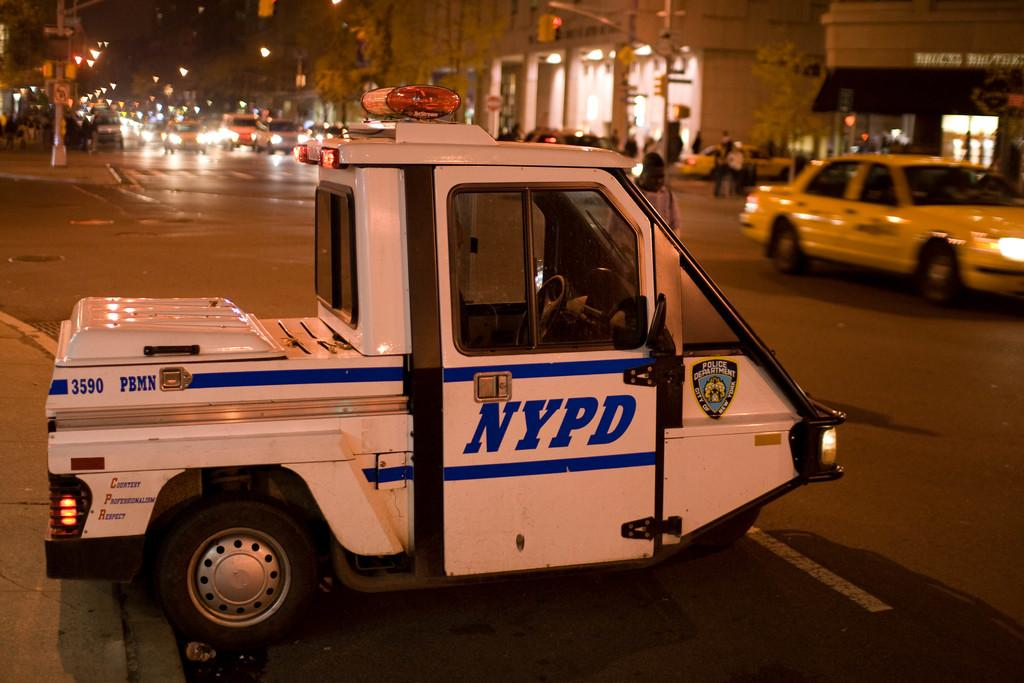<image>
Summarize the visual content of the image. The white mini car shown is an NYPD car. 